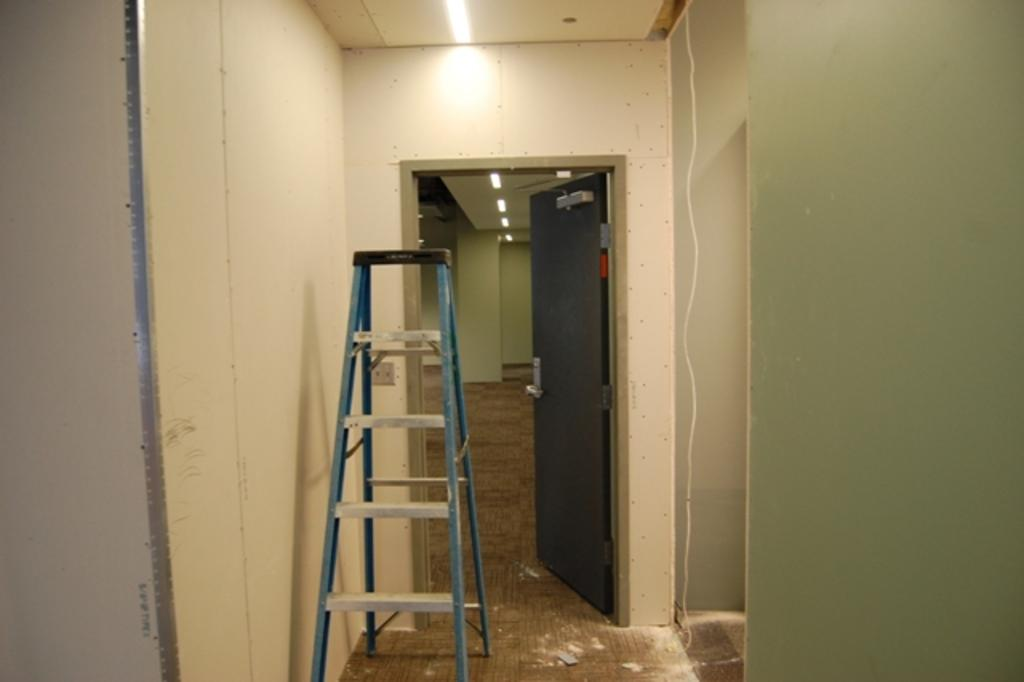What object in the image can be used for climbing or reaching higher places? There is a ladder in the image that can be used for climbing or reaching higher places. What feature in the image can be used for entering or exiting a room? There is a door in the image that can be used for entering or exiting a room. What color is the wall in the image? The wall in the image is cream-colored. What type of songs can be heard being sung by the iron in the image? There is no iron present in the image, and therefore no songs can be heard being sung by it. 